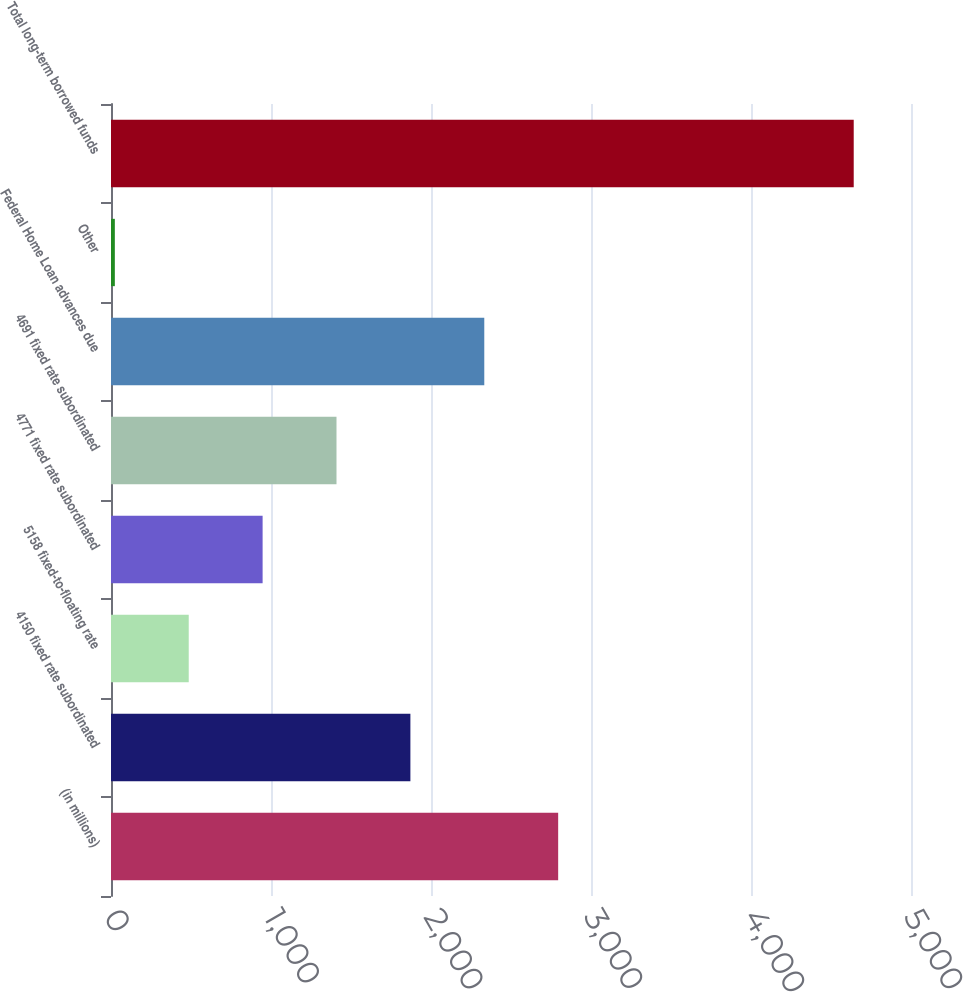Convert chart. <chart><loc_0><loc_0><loc_500><loc_500><bar_chart><fcel>(in millions)<fcel>4150 fixed rate subordinated<fcel>5158 fixed-to-floating rate<fcel>4771 fixed rate subordinated<fcel>4691 fixed rate subordinated<fcel>Federal Home Loan advances due<fcel>Other<fcel>Total long-term borrowed funds<nl><fcel>2794.8<fcel>1871.2<fcel>485.8<fcel>947.6<fcel>1409.4<fcel>2333<fcel>24<fcel>4642<nl></chart> 